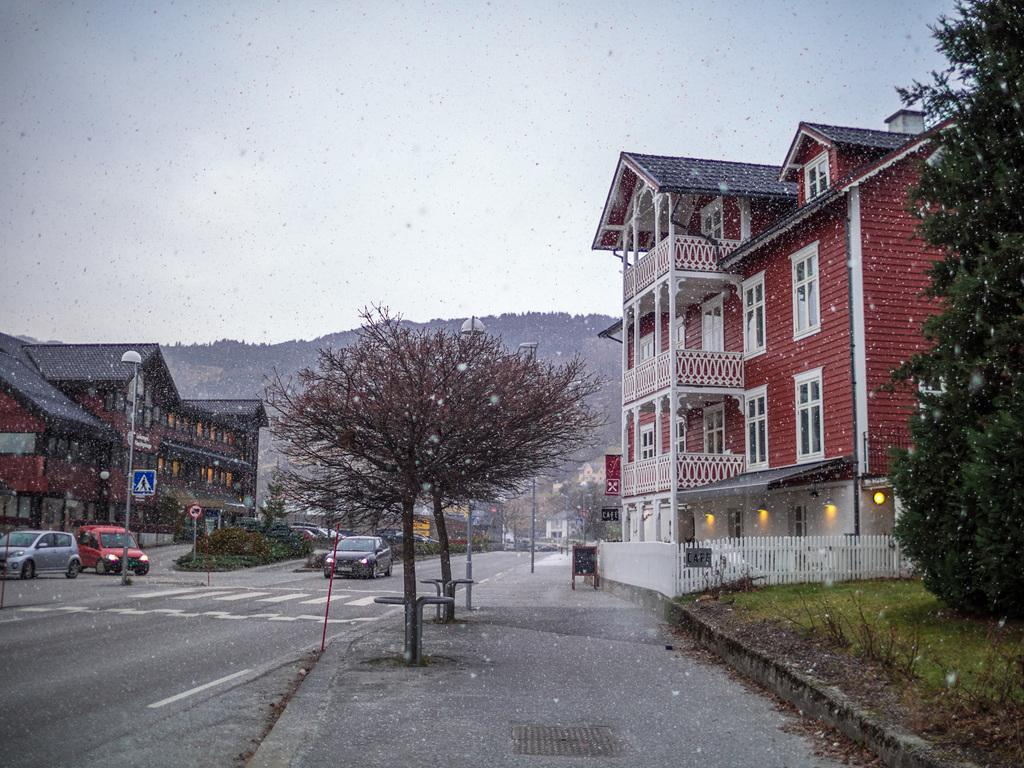What can be seen on the road in the image? There are vehicles on the road in the image. What is located beside the road in the image? Poles, chairs, trees, and sign boards are located beside the road in the image. What can be seen in the sky in the image? Lights are visible in the image. What structures can be seen in the background of the image? Buildings and hills are visible in the image. What type of action are the giants performing in the image? There are no giants present in the image, so no such action can be observed. Can you tell me where the stove is located in the image? There is no stove present in the image. 